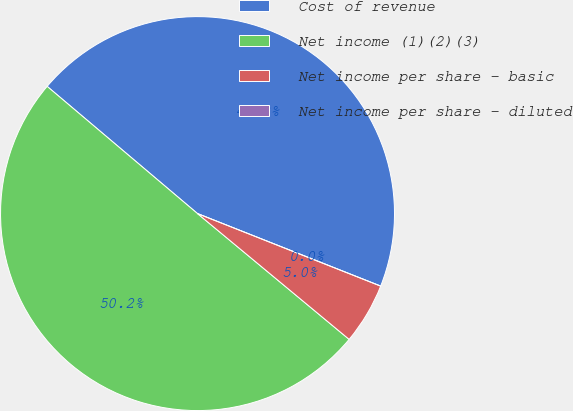Convert chart. <chart><loc_0><loc_0><loc_500><loc_500><pie_chart><fcel>Cost of revenue<fcel>Net income (1)(2)(3)<fcel>Net income per share - basic<fcel>Net income per share - diluted<nl><fcel>44.83%<fcel>50.16%<fcel>5.02%<fcel>0.0%<nl></chart> 